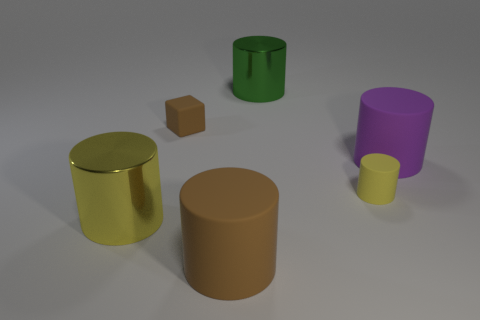Does the green object have the same size as the brown block?
Give a very brief answer. No. How many objects are either small cylinders or rubber objects that are behind the small yellow object?
Provide a short and direct response. 3. What material is the big purple cylinder?
Give a very brief answer. Rubber. Are there any other things of the same color as the small rubber block?
Ensure brevity in your answer.  Yes. Does the purple object have the same shape as the yellow rubber object?
Your answer should be very brief. Yes. There is a yellow object that is on the right side of the green cylinder behind the rubber object that is on the left side of the big brown rubber object; how big is it?
Offer a very short reply. Small. How many other objects are the same material as the big purple object?
Offer a very short reply. 3. What color is the big rubber cylinder that is in front of the yellow metallic cylinder?
Your response must be concise. Brown. The yellow cylinder to the right of the metallic cylinder that is in front of the big matte cylinder on the right side of the big brown cylinder is made of what material?
Offer a very short reply. Rubber. Are there any gray rubber objects that have the same shape as the large yellow object?
Make the answer very short. No. 